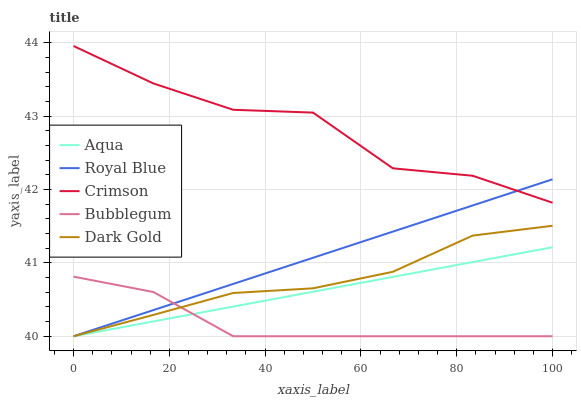Does Bubblegum have the minimum area under the curve?
Answer yes or no. Yes. Does Crimson have the maximum area under the curve?
Answer yes or no. Yes. Does Royal Blue have the minimum area under the curve?
Answer yes or no. No. Does Royal Blue have the maximum area under the curve?
Answer yes or no. No. Is Aqua the smoothest?
Answer yes or no. Yes. Is Crimson the roughest?
Answer yes or no. Yes. Is Royal Blue the smoothest?
Answer yes or no. No. Is Royal Blue the roughest?
Answer yes or no. No. Does Royal Blue have the lowest value?
Answer yes or no. Yes. Does Crimson have the highest value?
Answer yes or no. Yes. Does Royal Blue have the highest value?
Answer yes or no. No. Is Aqua less than Crimson?
Answer yes or no. Yes. Is Crimson greater than Bubblegum?
Answer yes or no. Yes. Does Bubblegum intersect Dark Gold?
Answer yes or no. Yes. Is Bubblegum less than Dark Gold?
Answer yes or no. No. Is Bubblegum greater than Dark Gold?
Answer yes or no. No. Does Aqua intersect Crimson?
Answer yes or no. No. 